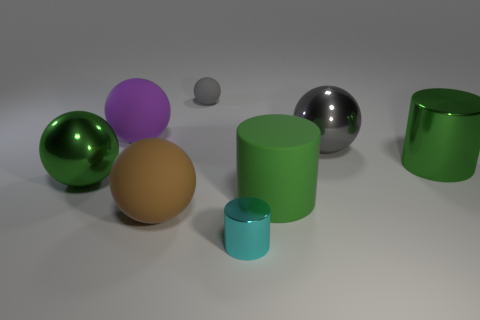Subtract all purple balls. How many balls are left? 4 Subtract all large green balls. How many balls are left? 4 Subtract all green balls. Subtract all blue cubes. How many balls are left? 4 Add 1 cyan cylinders. How many objects exist? 9 Subtract all cylinders. How many objects are left? 5 Subtract 0 yellow spheres. How many objects are left? 8 Subtract all tiny green shiny cylinders. Subtract all large gray metal balls. How many objects are left? 7 Add 4 tiny shiny things. How many tiny shiny things are left? 5 Add 8 big green rubber things. How many big green rubber things exist? 9 